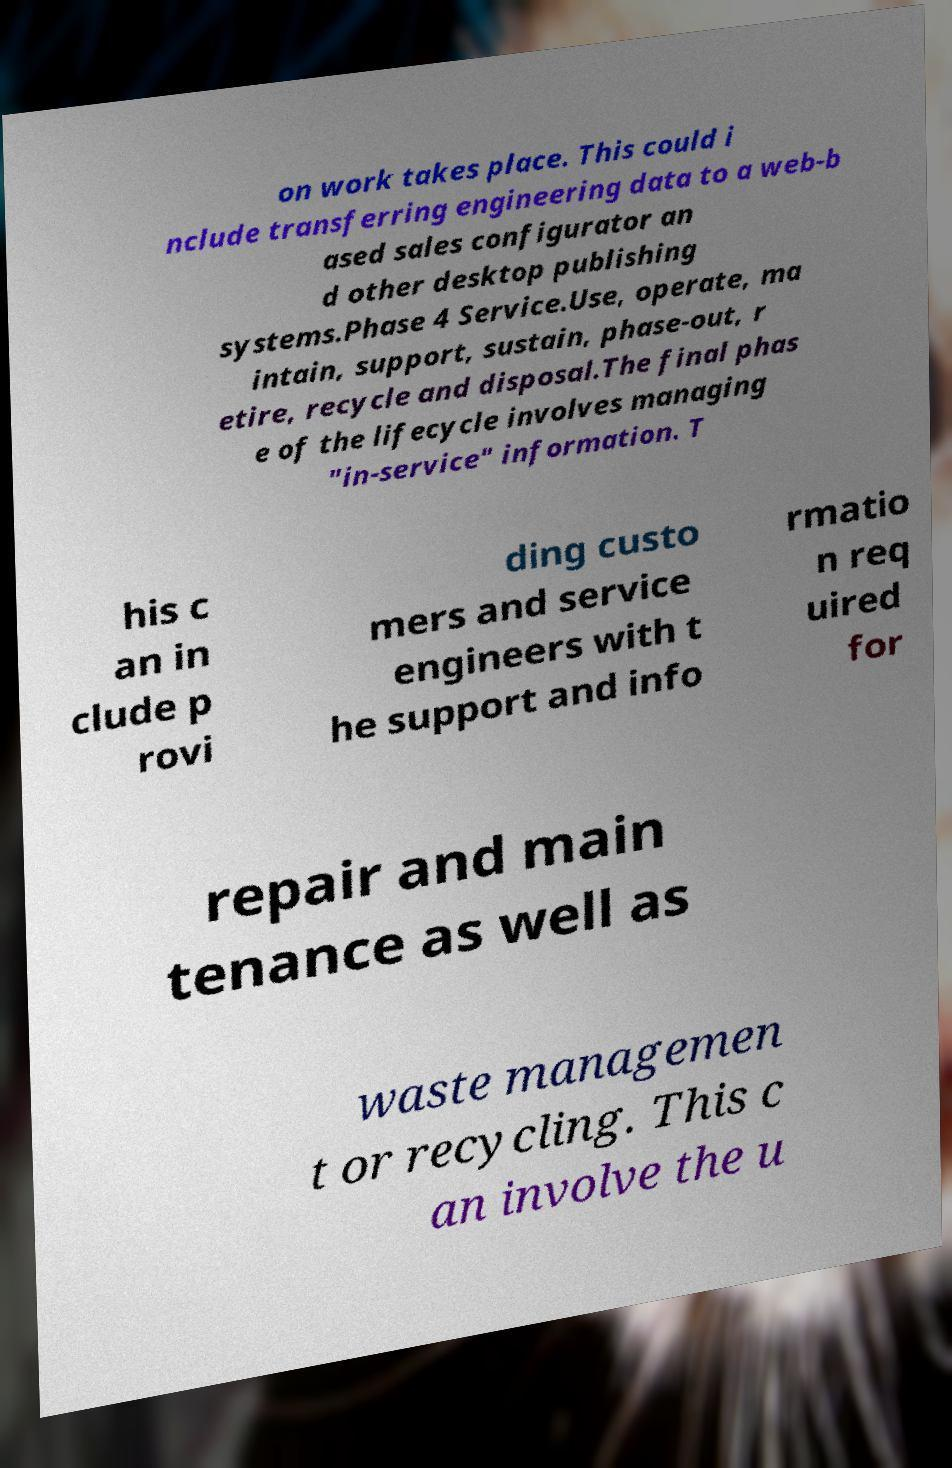Please identify and transcribe the text found in this image. on work takes place. This could i nclude transferring engineering data to a web-b ased sales configurator an d other desktop publishing systems.Phase 4 Service.Use, operate, ma intain, support, sustain, phase-out, r etire, recycle and disposal.The final phas e of the lifecycle involves managing "in-service" information. T his c an in clude p rovi ding custo mers and service engineers with t he support and info rmatio n req uired for repair and main tenance as well as waste managemen t or recycling. This c an involve the u 